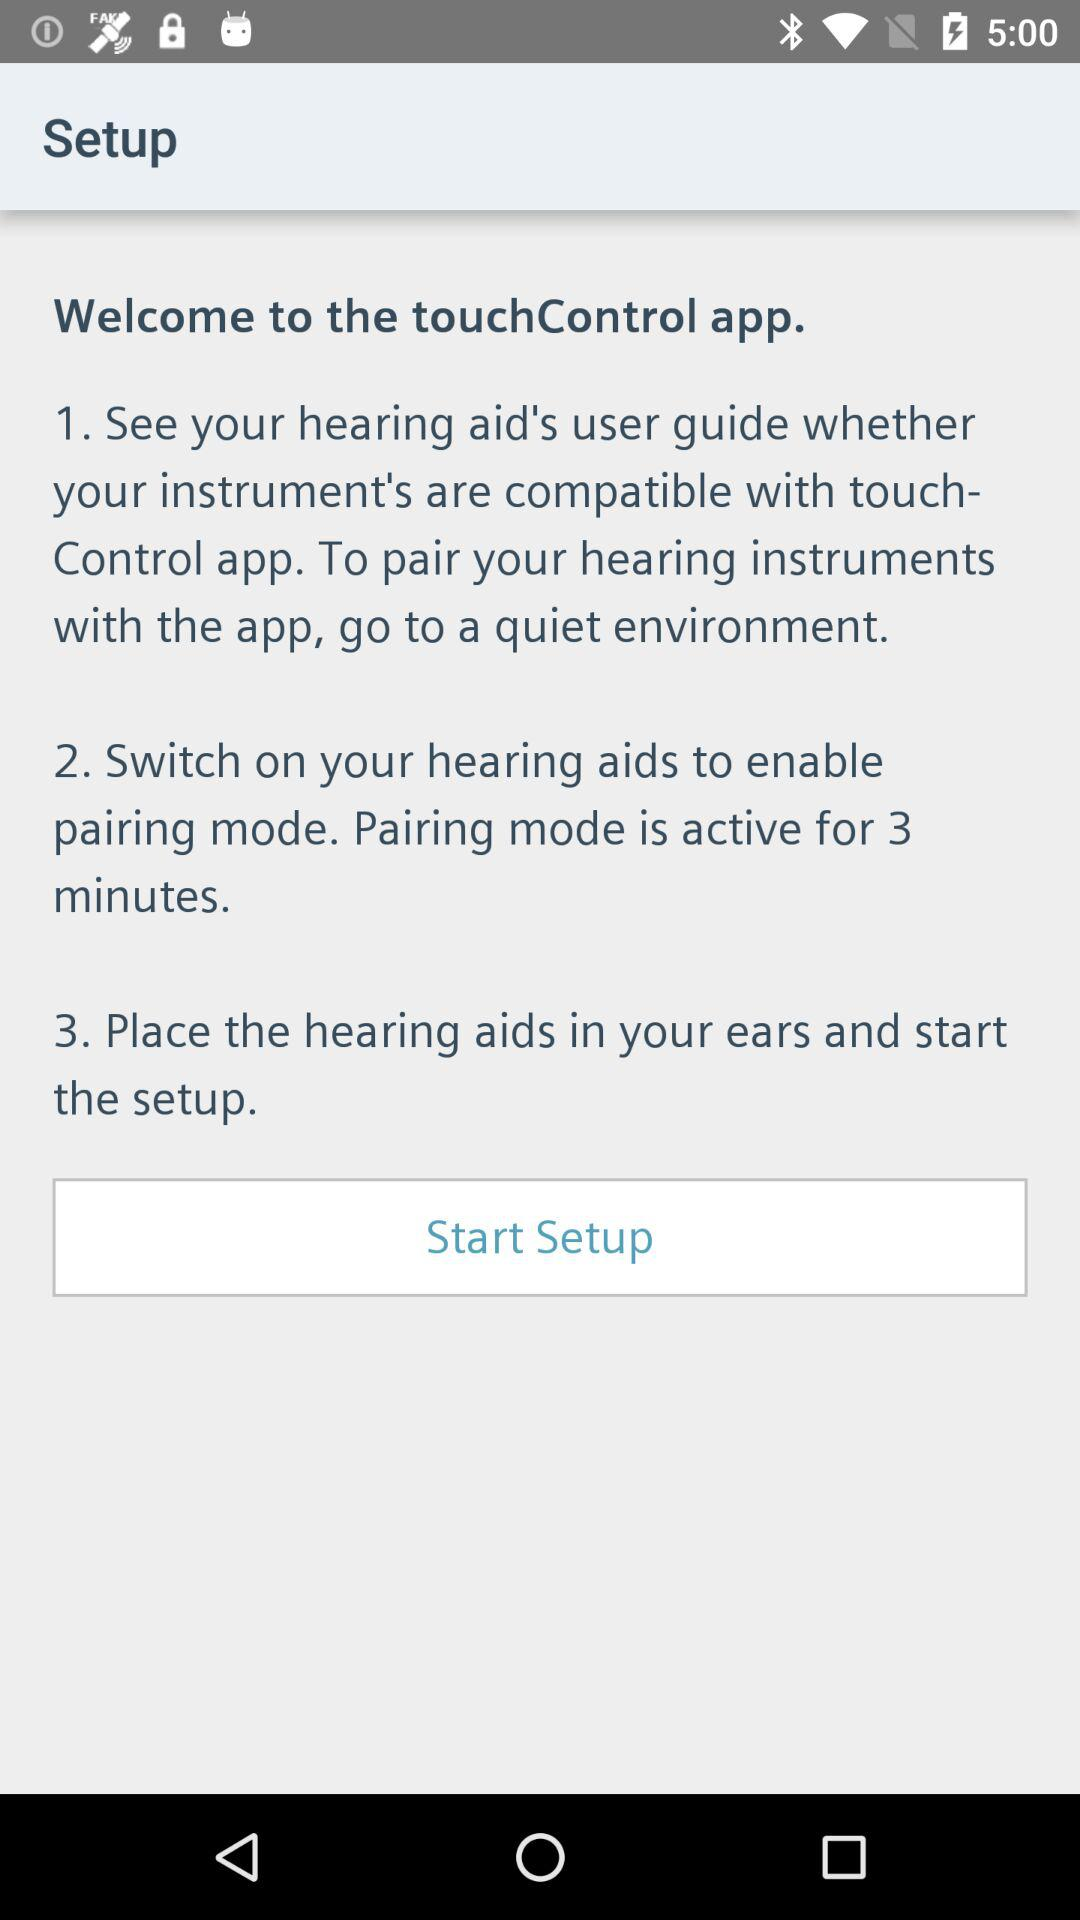How long is the pairing mode active for?
Answer the question using a single word or phrase. 3 minutes 